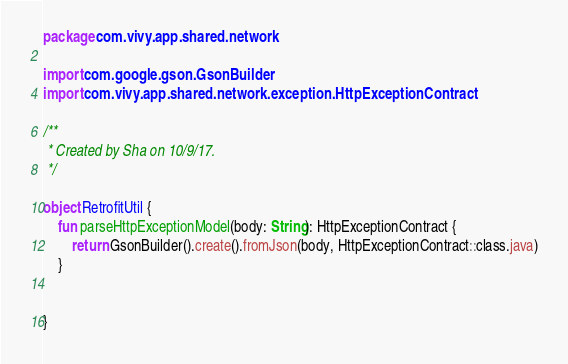<code> <loc_0><loc_0><loc_500><loc_500><_Kotlin_>package com.vivy.app.shared.network

import com.google.gson.GsonBuilder
import com.vivy.app.shared.network.exception.HttpExceptionContract

/**
 * Created by Sha on 10/9/17.
 */

object RetrofitUtil {
    fun parseHttpExceptionModel(body: String): HttpExceptionContract {
        return GsonBuilder().create().fromJson(body, HttpExceptionContract::class.java)
    }


}
</code> 